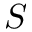Convert formula to latex. <formula><loc_0><loc_0><loc_500><loc_500>S</formula> 